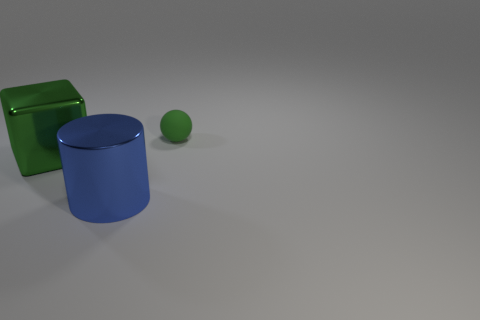Add 2 matte cubes. How many objects exist? 5 Subtract all blocks. How many objects are left? 2 Add 1 balls. How many balls are left? 2 Add 2 big blocks. How many big blocks exist? 3 Subtract 1 green blocks. How many objects are left? 2 Subtract all green spheres. Subtract all rubber objects. How many objects are left? 1 